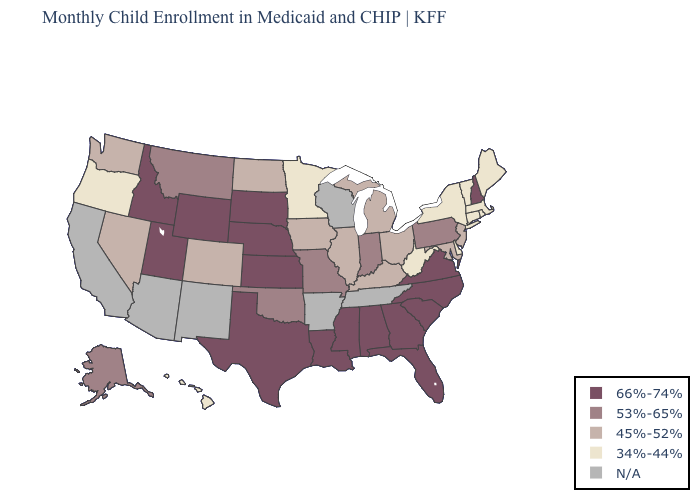Name the states that have a value in the range 66%-74%?
Write a very short answer. Alabama, Florida, Georgia, Idaho, Kansas, Louisiana, Mississippi, Nebraska, New Hampshire, North Carolina, South Carolina, South Dakota, Texas, Utah, Virginia, Wyoming. Name the states that have a value in the range 45%-52%?
Short answer required. Colorado, Illinois, Iowa, Kentucky, Maryland, Michigan, Nevada, New Jersey, North Dakota, Ohio, Washington. Among the states that border Utah , which have the lowest value?
Be succinct. Colorado, Nevada. Name the states that have a value in the range N/A?
Give a very brief answer. Arizona, Arkansas, California, New Mexico, Tennessee, Wisconsin. Does North Dakota have the lowest value in the USA?
Quick response, please. No. What is the value of Delaware?
Keep it brief. 34%-44%. Does the map have missing data?
Answer briefly. Yes. Name the states that have a value in the range 53%-65%?
Write a very short answer. Alaska, Indiana, Missouri, Montana, Oklahoma, Pennsylvania. What is the value of Massachusetts?
Short answer required. 34%-44%. Is the legend a continuous bar?
Concise answer only. No. What is the value of Mississippi?
Answer briefly. 66%-74%. Name the states that have a value in the range 66%-74%?
Answer briefly. Alabama, Florida, Georgia, Idaho, Kansas, Louisiana, Mississippi, Nebraska, New Hampshire, North Carolina, South Carolina, South Dakota, Texas, Utah, Virginia, Wyoming. What is the value of Mississippi?
Short answer required. 66%-74%. What is the value of Wyoming?
Give a very brief answer. 66%-74%. Name the states that have a value in the range 53%-65%?
Be succinct. Alaska, Indiana, Missouri, Montana, Oklahoma, Pennsylvania. 